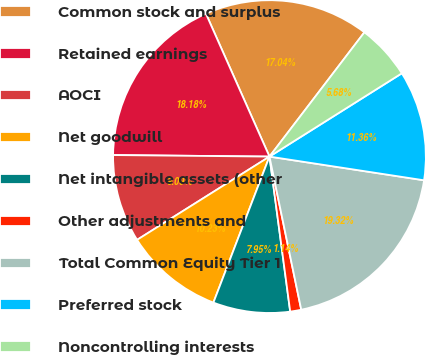Convert chart. <chart><loc_0><loc_0><loc_500><loc_500><pie_chart><fcel>Common stock and surplus<fcel>Retained earnings<fcel>AOCI<fcel>Net goodwill<fcel>Net intangible assets (other<fcel>Other adjustments and<fcel>Total Common Equity Tier 1<fcel>Preferred stock<fcel>Noncontrolling interests<nl><fcel>17.04%<fcel>18.18%<fcel>9.09%<fcel>10.23%<fcel>7.95%<fcel>1.14%<fcel>19.32%<fcel>11.36%<fcel>5.68%<nl></chart> 